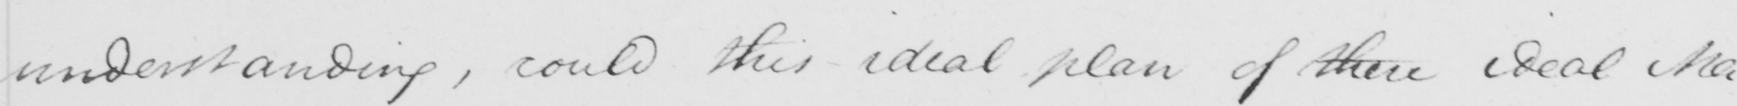Transcribe the text shown in this historical manuscript line. understanding , could these ideal plans of these ideal Ma- 